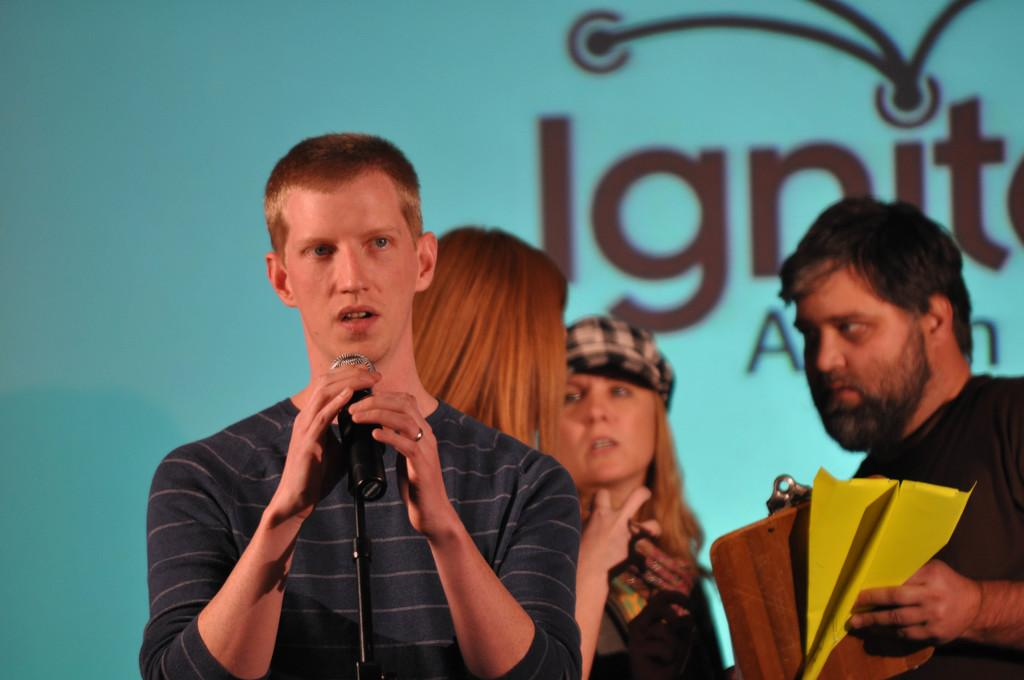What is the person in the image doing? The person is standing in front of a microphone. Are there any other people in the image? Yes, there are two ladies standing behind the person and another person standing near the ladies. How many umbrellas are visible in the image? There are no umbrellas visible in the image. What is the numerical value of the heart symbol in the image? There is no heart symbol present in the image. 